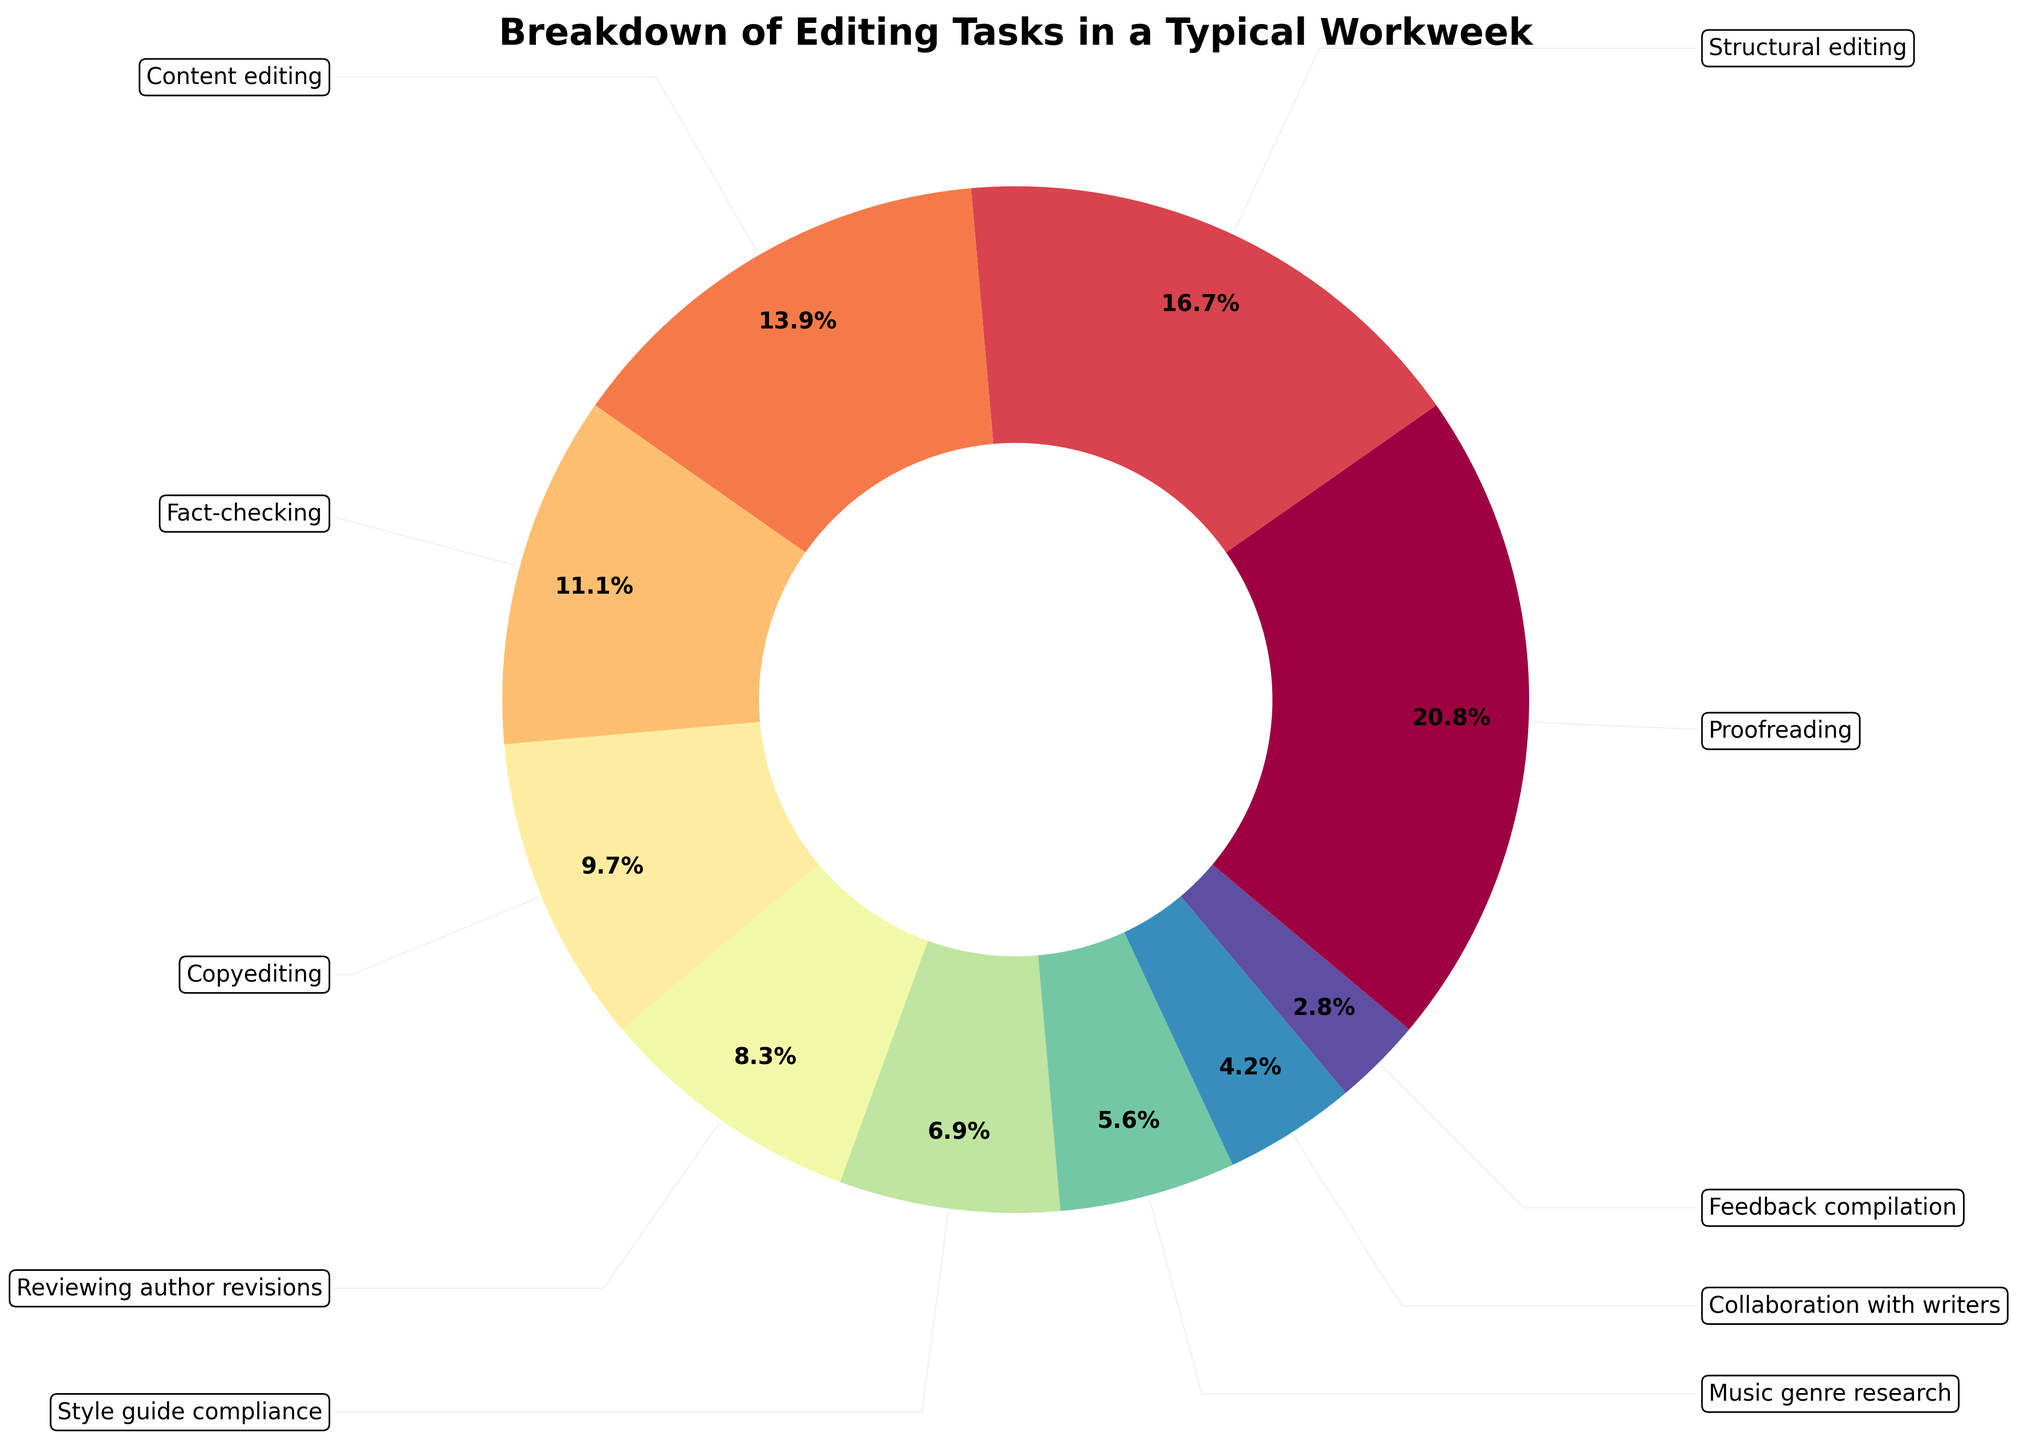What's the total number of hours spent on editing tasks in a typical workweek? To find the total number of hours, sum all the hours given for each task. Thus, 15 + 12 + 10 + 8 + 7 + 6 + 5 + 4 + 3 + 2 = 72 hours.
Answer: 72 Which task takes the highest proportion of time? The task with the highest number of hours will take the highest proportion of time. From the data, proofreading has the most hours (15) and thus the largest slice in the pie chart.
Answer: Proofreading How much more time is spent on proofreading compared to fact-checking? Subtract the hours spent on fact-checking from the hours spent on proofreading. That is, 15 - 8 = 7 hours.
Answer: 7 What tasks combined take up the same amount of time as proofreading? Look for tasks whose combined hours add up to 15. Content editing (10) + collaboration with writers (3) + feedback compilation (2) = 15 hours.
Answer: Content editing, collaboration with writers, feedback compilation What percentage of the workweek is dedicated to music genre research? According to the pie chart, music genre research is given 4 hours. To find the percentage, divide the hours spent on music genre research by the total hours and multiply by 100. Thus, (4 / 72) * 100 ≈ 5.6%.
Answer: 5.6% Is the time spent on structural editing greater than the time spent on content editing and feedback compilation combined? First, sum the hours of content editing and feedback compilation: 10 + 2 = 12. Since structural editing is also 12 hours, they are equal.
Answer: No, they are equal Which task is represented by the smallest section in the pie chart? The task with the lowest number of hours has the smallest section. Feedback compilation has 2 hours, the smallest number.
Answer: Feedback compilation What is the combined percentage of time spent on reviewing author revisions and style guide compliance? Review the hours of both tasks: reviewing author revisions (6 hours) and style guide compliance (5 hours), thus 6 + 5 = 11 hours. Then, (11 / 72) * 100 ≈ 15.3%.
Answer: 15.3% Compare the time spent on copyediting and collaboration with writers. Which one takes more time? Copyediting has 7 hours, while collaboration with writers has 3 hours, so copyediting takes more time.
Answer: Copyediting Among proofreading, structural editing, and content editing, which task utilizes the median amount of time? List the hours of these tasks: proofreading (15), structural editing (12), and content editing (10). The median value is the middle number when sorted, so 12 hours (structural editing).
Answer: Structural editing 